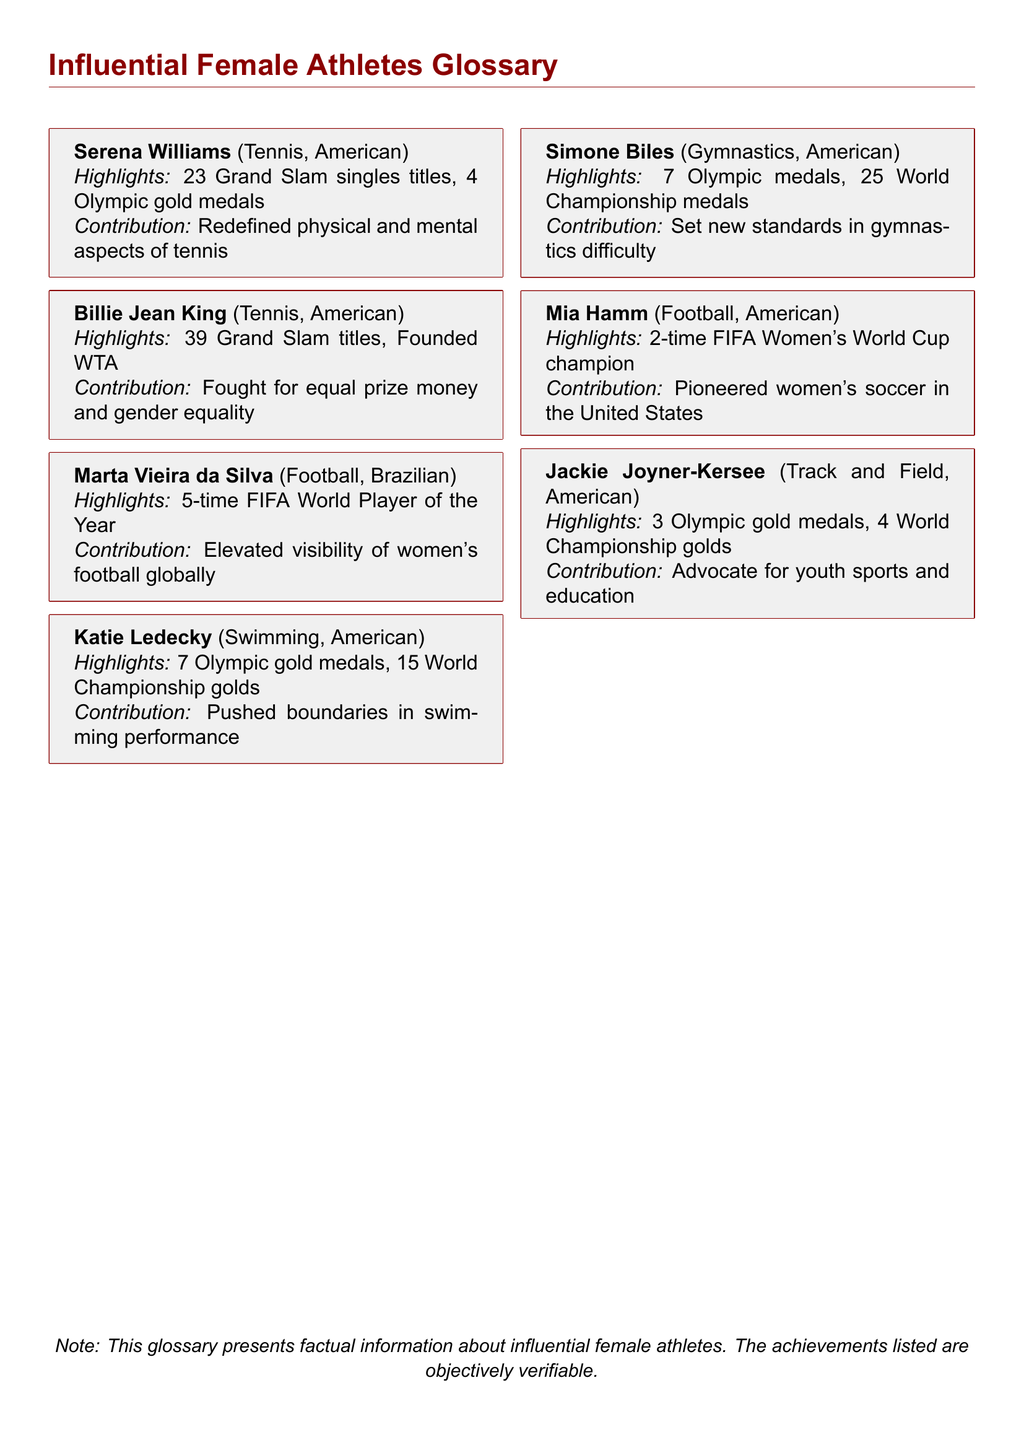What is the nationality of Serena Williams? The document states that Serena Williams is American.
Answer: American How many Olympic gold medals does Simone Biles have? According to the document, Simone Biles has 7 Olympic medals, which includes her gold medals.
Answer: 7 What sport is Marta Vieira da Silva associated with? The document indicates that Marta Vieira da Silva is associated with football.
Answer: Football How many Grand Slam singles titles does Serena Williams have? The document mentions that Serena Williams has 23 Grand Slam singles titles.
Answer: 23 Who founded the WTA? The document states that Billie Jean King founded the WTA.
Answer: Billie Jean King What is the main contribution of Mia Hamm mentioned in the document? The document highlights Mia Hamm's contribution as pioneering women's soccer in the United States.
Answer: Pioneered women's soccer in the United States How many times has Jackie Joyner-Kersee won Olympic gold medals? The document indicates that Jackie Joyner-Kersee has won 3 Olympic gold medals.
Answer: 3 Which athlete has the most World Championship medals listed in the document? The document states that Simone Biles has 25 World Championship medals, which is the highest among the athletes listed.
Answer: Simone Biles What sport does Katie Ledecky compete in? The document specifies that Katie Ledecky competes in swimming.
Answer: Swimming 